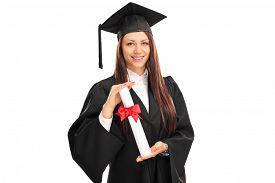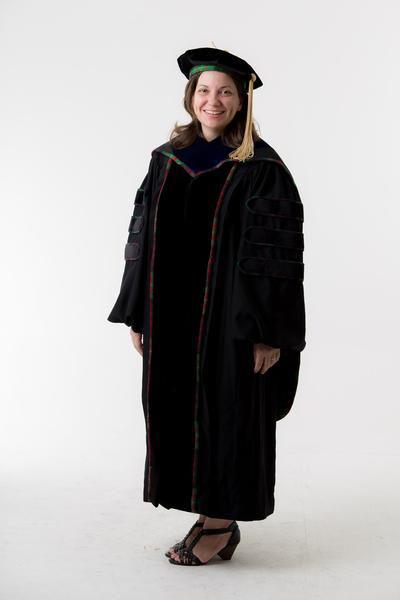The first image is the image on the left, the second image is the image on the right. Examine the images to the left and right. Is the description "In one image a graduation gown worn by a woman is black and red." accurate? Answer yes or no. No. 